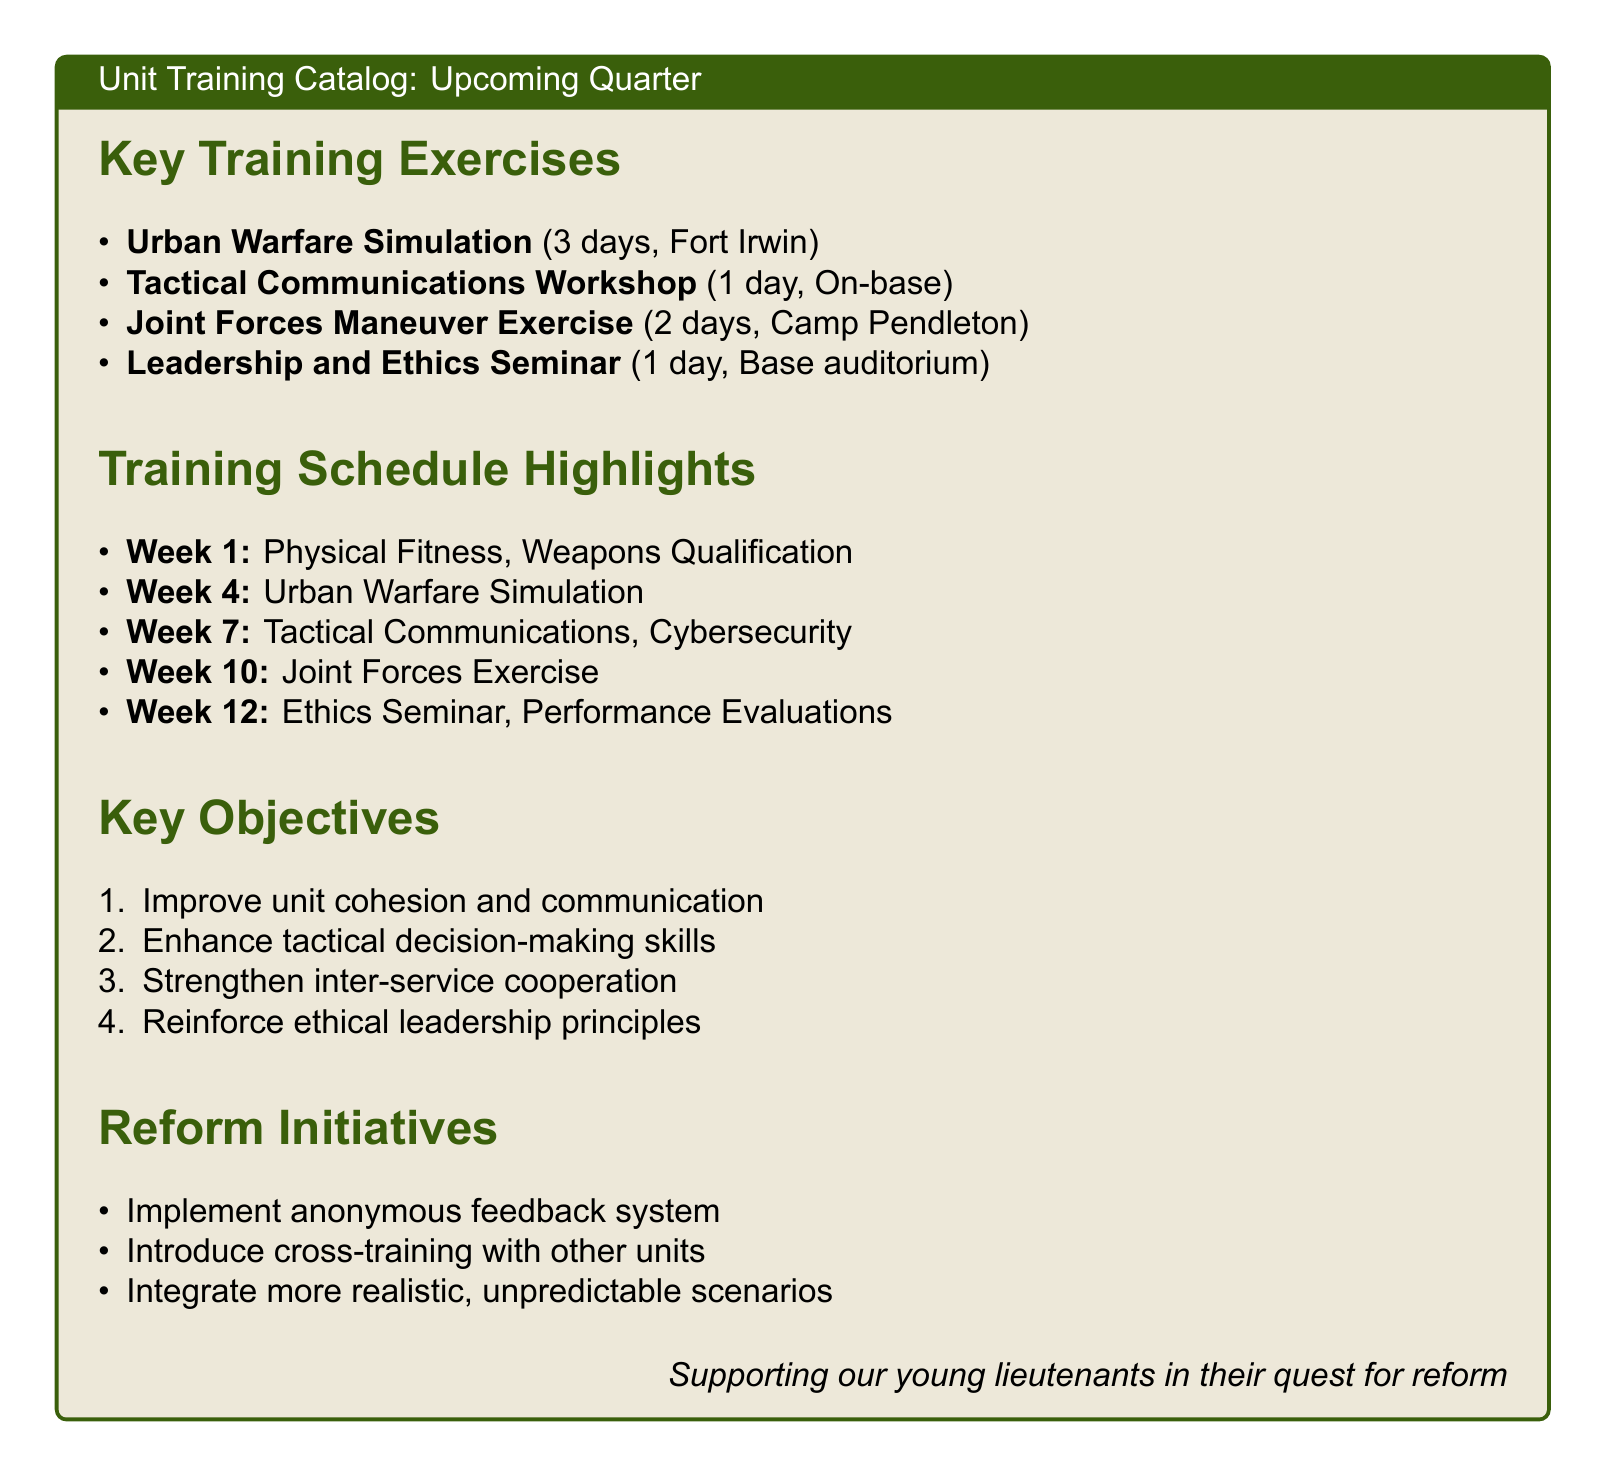What is the location of the Urban Warfare Simulation? The location is specified in the document, stating it is at Fort Irwin.
Answer: Fort Irwin How many days does the Tactical Communications Workshop last? The duration of the Tactical Communications Workshop is mentioned in the document as 1 day.
Answer: 1 day What is the focus of the Leadership and Ethics Seminar? The document indicates that the seminar focuses on leadership and ethics, which is a key topic.
Answer: Leadership and Ethics Which week includes the Joint Forces Exercise? The schedule in the document outlines that the Joint Forces Exercise takes place in Week 10.
Answer: Week 10 What initiative is aimed at improving communication? The document lists an anonymous feedback system aimed at enhancing communication.
Answer: Anonymous feedback system Identify one objective mentioned in the document. The document lists key objectives including improving unit cohesion.
Answer: Improve unit cohesion What type of exercise is the Joint Forces Maneuver Exercise categorized as? The document categorizes it as a key training exercise.
Answer: Key training exercise How many key training exercises are listed in the document? The document enumerates four key training exercises under the relevant section.
Answer: Four 